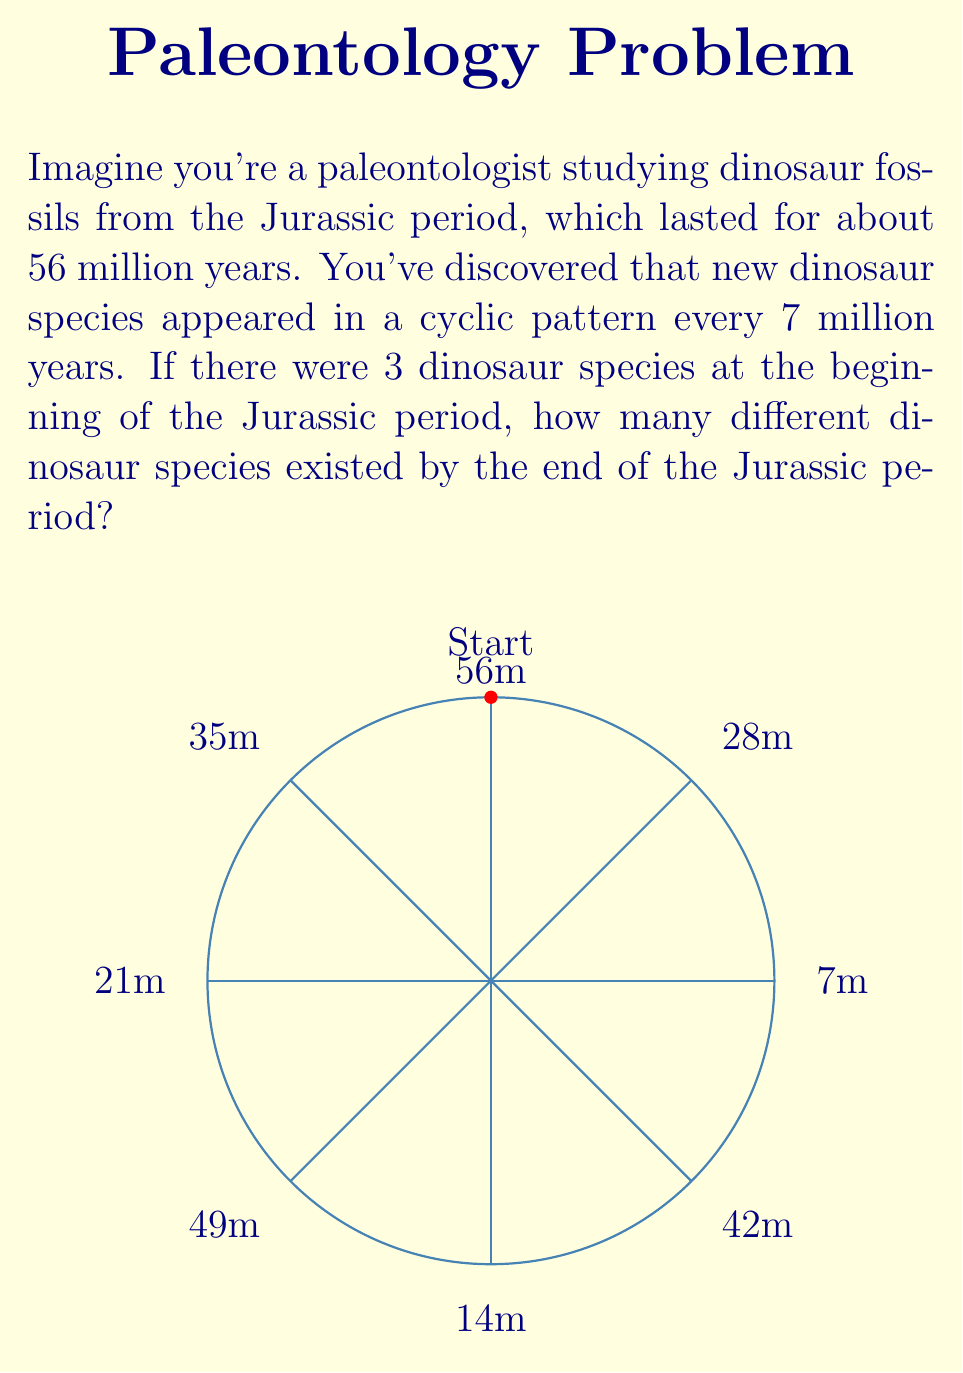Could you help me with this problem? Let's approach this step-by-step using cyclic group theory:

1) First, we need to determine how many complete cycles occurred during the Jurassic period:
   $$ \text{Number of cycles} = \left\lfloor\frac{56 \text{ million years}}{7 \text{ million years per cycle}}\right\rfloor = 8 $$

2) In cyclic group theory, we can represent this as $\mathbb{Z}_8$, the cyclic group of order 8.

3) Each element in this group represents a new set of dinosaur species. The initial state (0 in the group) represents the original 3 species.

4) In each subsequent state (1 to 7 in the group), a new set of species appears.

5) To find the total number of species, we need to sum all the new species plus the initial species:
   $$ \text{Total species} = 3 + \sum_{i=1}^{7} 1 = 3 + 7 = 10 $$

6) This can be generalized as:
   $$ \text{Total species} = \text{Initial species} + |\mathbb{Z}_8| - 1 $$
   Where $|\mathbb{Z}_8|$ is the order of the cyclic group.

Therefore, by the end of the Jurassic period, there were 10 different dinosaur species.
Answer: 10 species 